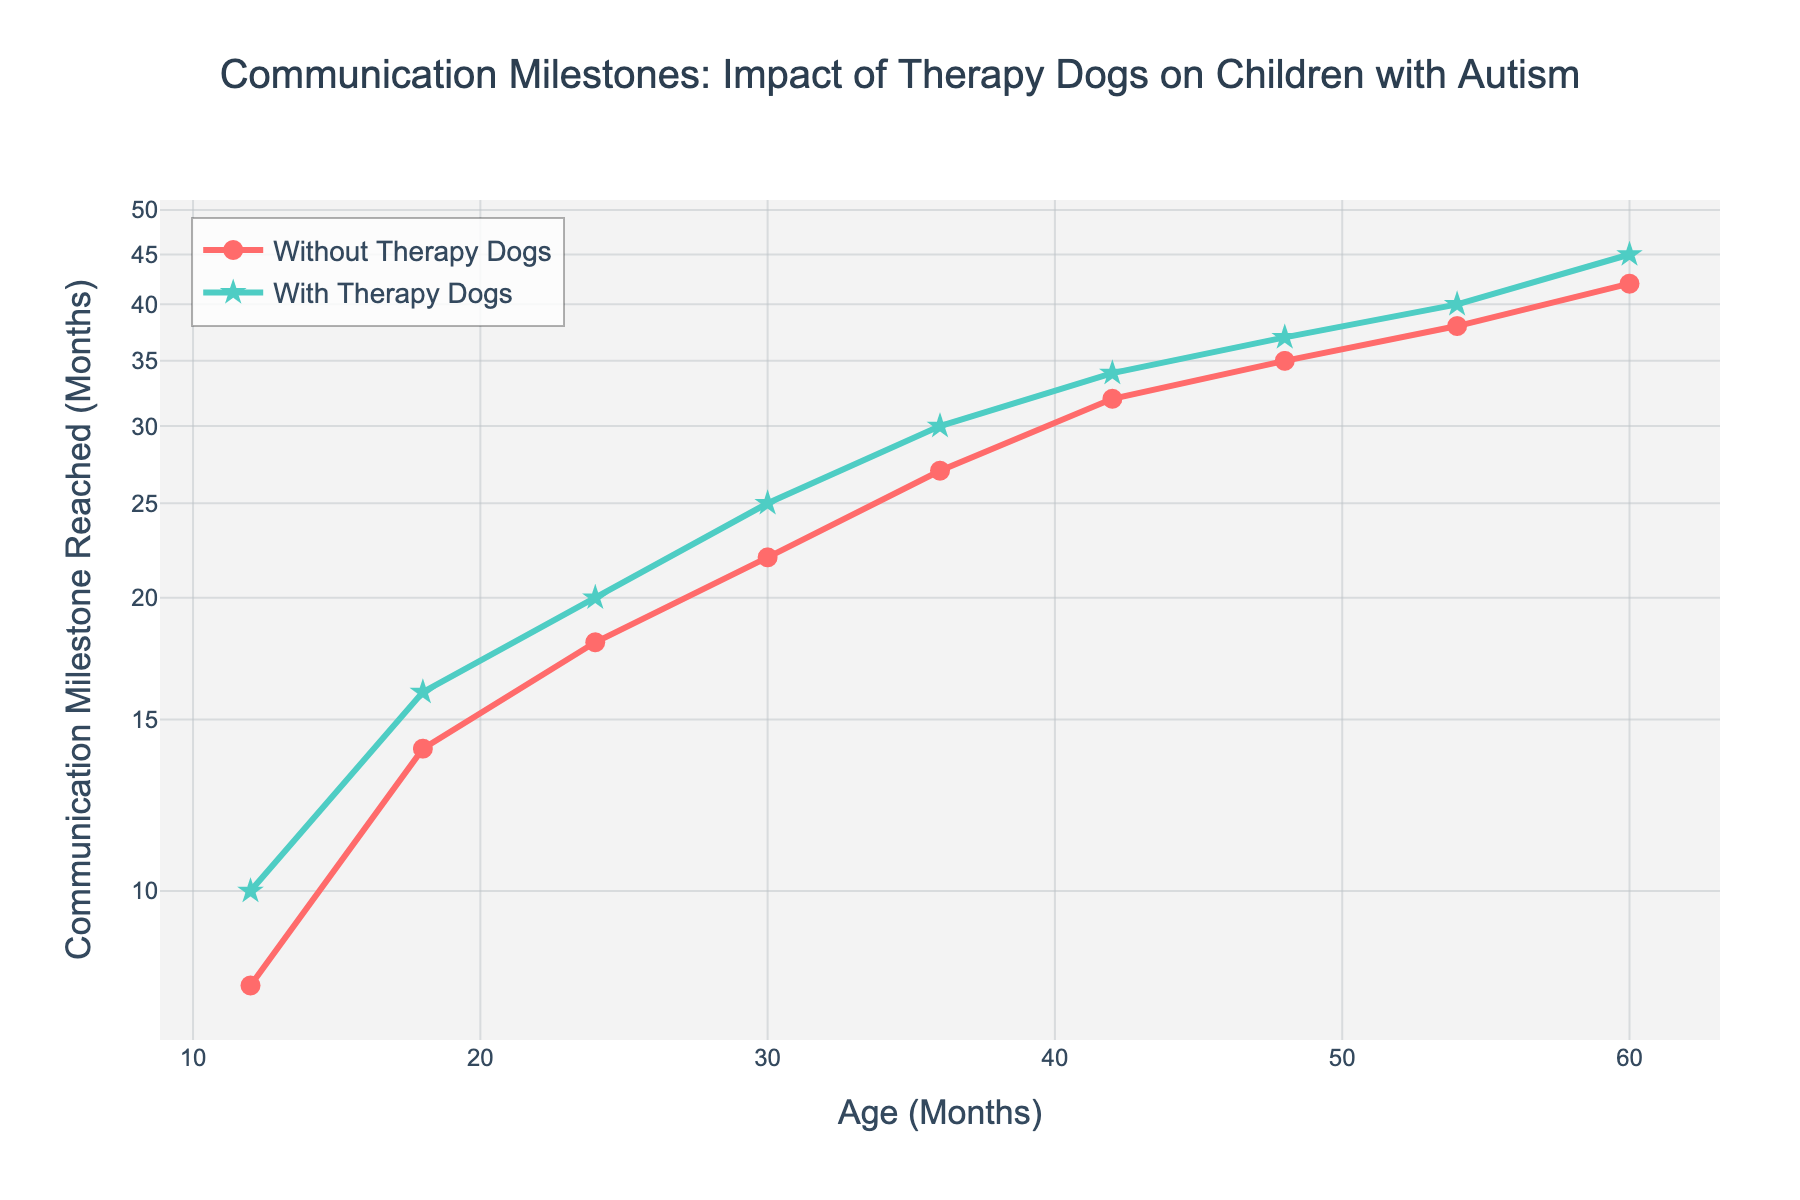What is the title of the figure? The title is placed at the top and centered, written in a larger font size and bold style. It describes the main focus of the plot.
Answer: Communication Milestones: Impact of Therapy Dogs on Children with Autism How many data points are shown for each group on the plotted lines? The plotted lines for both groups have markers indicating the data points. We count the markers for one of the groups.
Answer: 9 At 30 months, which group shows a higher communication milestone reached, and by how many months? Find the point where Age in Months is 30 on the x-axis, compare the y-values for both groups.
Answer: With Therapy Dogs by 3 months What is the y-axis label? The label for the y-axis describes what the y-values represent and is located along the vertical axis.
Answer: Communication Milestone Reached (Months) How does the trend of communication milestones reached differ between children with and without therapy dogs? Observe the slopes and patterns of the two lines. Compare how each line progresses as age increases.
Answer: Children with therapy dogs generally reach milestones later than those without therapy dogs Which group shows a larger increase in communication milestones reached between 42 and 54 months? Find the y-values for both groups at 42 and 54 months, then calculate the differences and compare.
Answer: Without Therapy Dogs Is there a point where both groups show the same communication milestone reached? If yes, at what age? Look for an intersection or points on the plot where the y-values for both groups are the same.
Answer: No What is the communication milestone reached by children with therapy dogs at 48 months? Find 48 on the x-axis and follow upwards to where it intersects with the 'With Therapy Dogs' line.
Answer: 37 months 